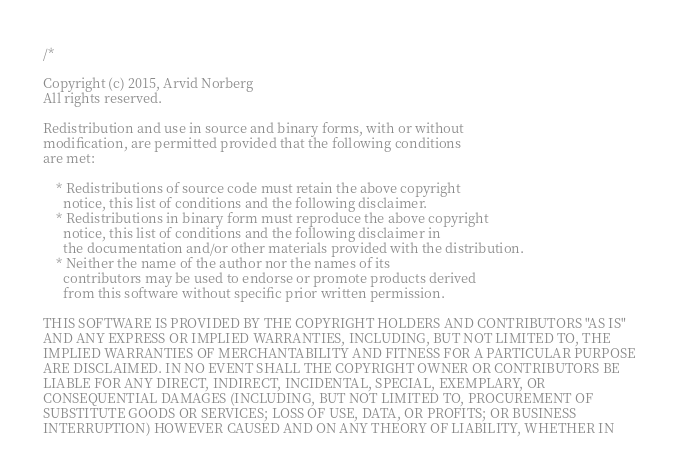<code> <loc_0><loc_0><loc_500><loc_500><_C++_>/*

Copyright (c) 2015, Arvid Norberg
All rights reserved.

Redistribution and use in source and binary forms, with or without
modification, are permitted provided that the following conditions
are met:

    * Redistributions of source code must retain the above copyright
      notice, this list of conditions and the following disclaimer.
    * Redistributions in binary form must reproduce the above copyright
      notice, this list of conditions and the following disclaimer in
      the documentation and/or other materials provided with the distribution.
    * Neither the name of the author nor the names of its
      contributors may be used to endorse or promote products derived
      from this software without specific prior written permission.

THIS SOFTWARE IS PROVIDED BY THE COPYRIGHT HOLDERS AND CONTRIBUTORS "AS IS"
AND ANY EXPRESS OR IMPLIED WARRANTIES, INCLUDING, BUT NOT LIMITED TO, THE
IMPLIED WARRANTIES OF MERCHANTABILITY AND FITNESS FOR A PARTICULAR PURPOSE
ARE DISCLAIMED. IN NO EVENT SHALL THE COPYRIGHT OWNER OR CONTRIBUTORS BE
LIABLE FOR ANY DIRECT, INDIRECT, INCIDENTAL, SPECIAL, EXEMPLARY, OR
CONSEQUENTIAL DAMAGES (INCLUDING, BUT NOT LIMITED TO, PROCUREMENT OF
SUBSTITUTE GOODS OR SERVICES; LOSS OF USE, DATA, OR PROFITS; OR BUSINESS
INTERRUPTION) HOWEVER CAUSED AND ON ANY THEORY OF LIABILITY, WHETHER IN</code> 